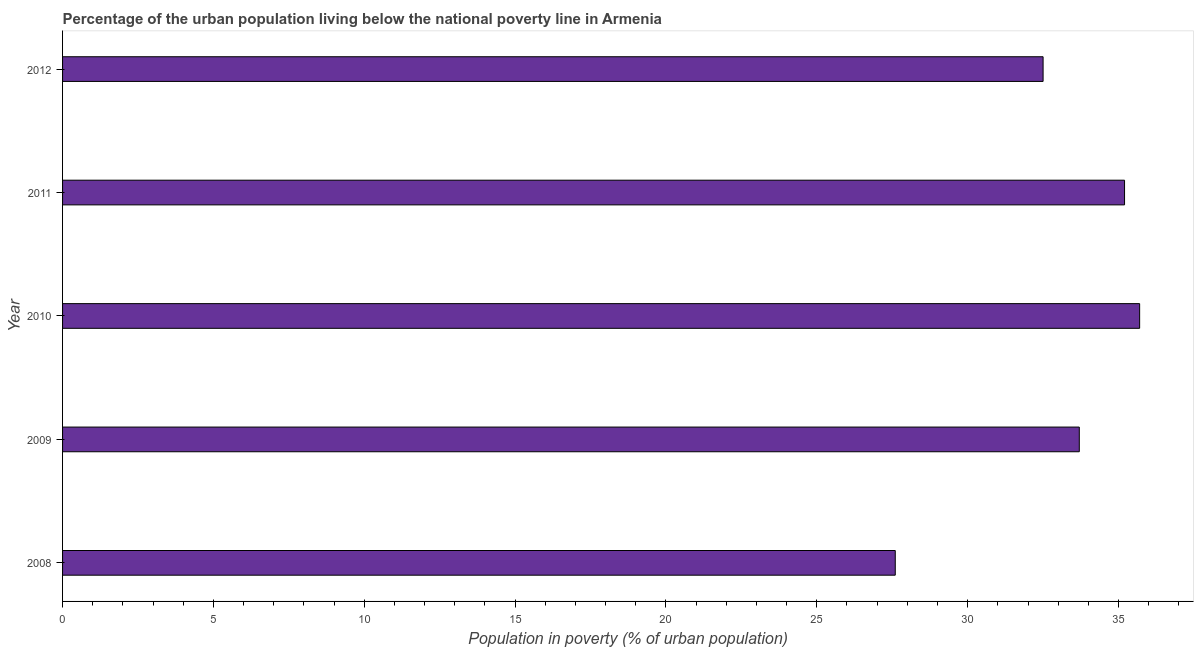Does the graph contain any zero values?
Give a very brief answer. No. What is the title of the graph?
Ensure brevity in your answer.  Percentage of the urban population living below the national poverty line in Armenia. What is the label or title of the X-axis?
Make the answer very short. Population in poverty (% of urban population). What is the label or title of the Y-axis?
Keep it short and to the point. Year. What is the percentage of urban population living below poverty line in 2010?
Provide a short and direct response. 35.7. Across all years, what is the maximum percentage of urban population living below poverty line?
Provide a short and direct response. 35.7. Across all years, what is the minimum percentage of urban population living below poverty line?
Keep it short and to the point. 27.6. In which year was the percentage of urban population living below poverty line minimum?
Provide a short and direct response. 2008. What is the sum of the percentage of urban population living below poverty line?
Provide a succinct answer. 164.7. What is the average percentage of urban population living below poverty line per year?
Make the answer very short. 32.94. What is the median percentage of urban population living below poverty line?
Provide a short and direct response. 33.7. Do a majority of the years between 2008 and 2011 (inclusive) have percentage of urban population living below poverty line greater than 25 %?
Offer a very short reply. Yes. Is the sum of the percentage of urban population living below poverty line in 2009 and 2012 greater than the maximum percentage of urban population living below poverty line across all years?
Your answer should be very brief. Yes. What is the difference between the highest and the lowest percentage of urban population living below poverty line?
Keep it short and to the point. 8.1. How many years are there in the graph?
Offer a very short reply. 5. What is the Population in poverty (% of urban population) of 2008?
Offer a terse response. 27.6. What is the Population in poverty (% of urban population) in 2009?
Your response must be concise. 33.7. What is the Population in poverty (% of urban population) in 2010?
Your answer should be compact. 35.7. What is the Population in poverty (% of urban population) of 2011?
Make the answer very short. 35.2. What is the Population in poverty (% of urban population) in 2012?
Provide a succinct answer. 32.5. What is the difference between the Population in poverty (% of urban population) in 2008 and 2011?
Ensure brevity in your answer.  -7.6. What is the difference between the Population in poverty (% of urban population) in 2009 and 2011?
Give a very brief answer. -1.5. What is the difference between the Population in poverty (% of urban population) in 2009 and 2012?
Your response must be concise. 1.2. What is the ratio of the Population in poverty (% of urban population) in 2008 to that in 2009?
Provide a succinct answer. 0.82. What is the ratio of the Population in poverty (% of urban population) in 2008 to that in 2010?
Your response must be concise. 0.77. What is the ratio of the Population in poverty (% of urban population) in 2008 to that in 2011?
Offer a terse response. 0.78. What is the ratio of the Population in poverty (% of urban population) in 2008 to that in 2012?
Provide a succinct answer. 0.85. What is the ratio of the Population in poverty (% of urban population) in 2009 to that in 2010?
Your answer should be compact. 0.94. What is the ratio of the Population in poverty (% of urban population) in 2009 to that in 2011?
Provide a succinct answer. 0.96. What is the ratio of the Population in poverty (% of urban population) in 2009 to that in 2012?
Your answer should be compact. 1.04. What is the ratio of the Population in poverty (% of urban population) in 2010 to that in 2011?
Your answer should be compact. 1.01. What is the ratio of the Population in poverty (% of urban population) in 2010 to that in 2012?
Give a very brief answer. 1.1. What is the ratio of the Population in poverty (% of urban population) in 2011 to that in 2012?
Provide a short and direct response. 1.08. 